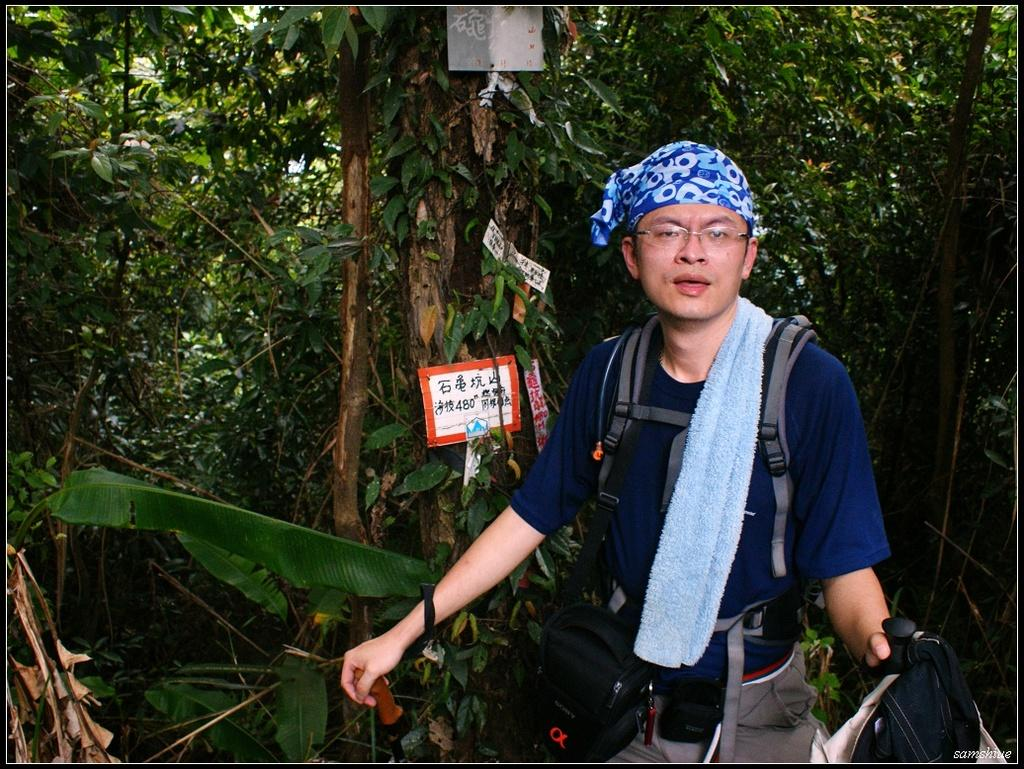What is present in the image? There is a person in the image. What is the person wearing? The person is wearing a bag. What is the person holding? The person is holding an object. What can be seen in the foreground of the image? There is a board with text in the foreground of the image. What is visible in the background of the image? There are trees in the background of the image. What type of stove is being used by the manager in the image? There is no stove or manager present in the image. 